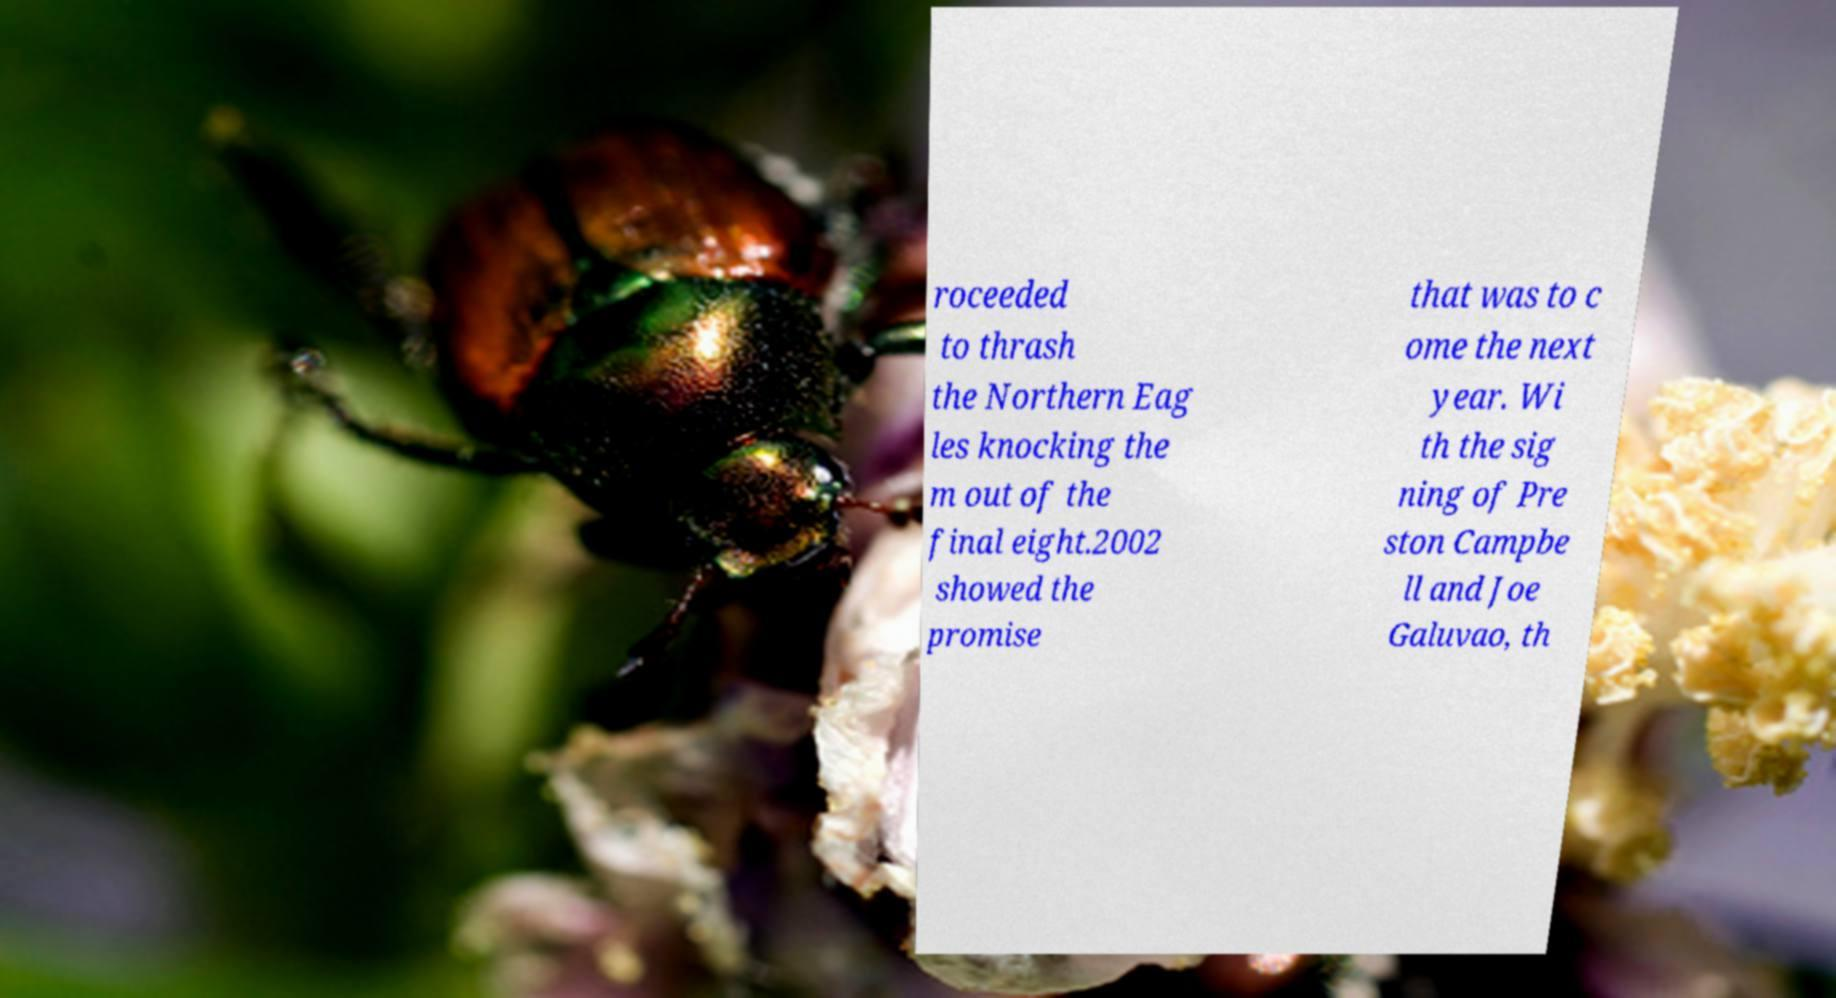Could you assist in decoding the text presented in this image and type it out clearly? roceeded to thrash the Northern Eag les knocking the m out of the final eight.2002 showed the promise that was to c ome the next year. Wi th the sig ning of Pre ston Campbe ll and Joe Galuvao, th 